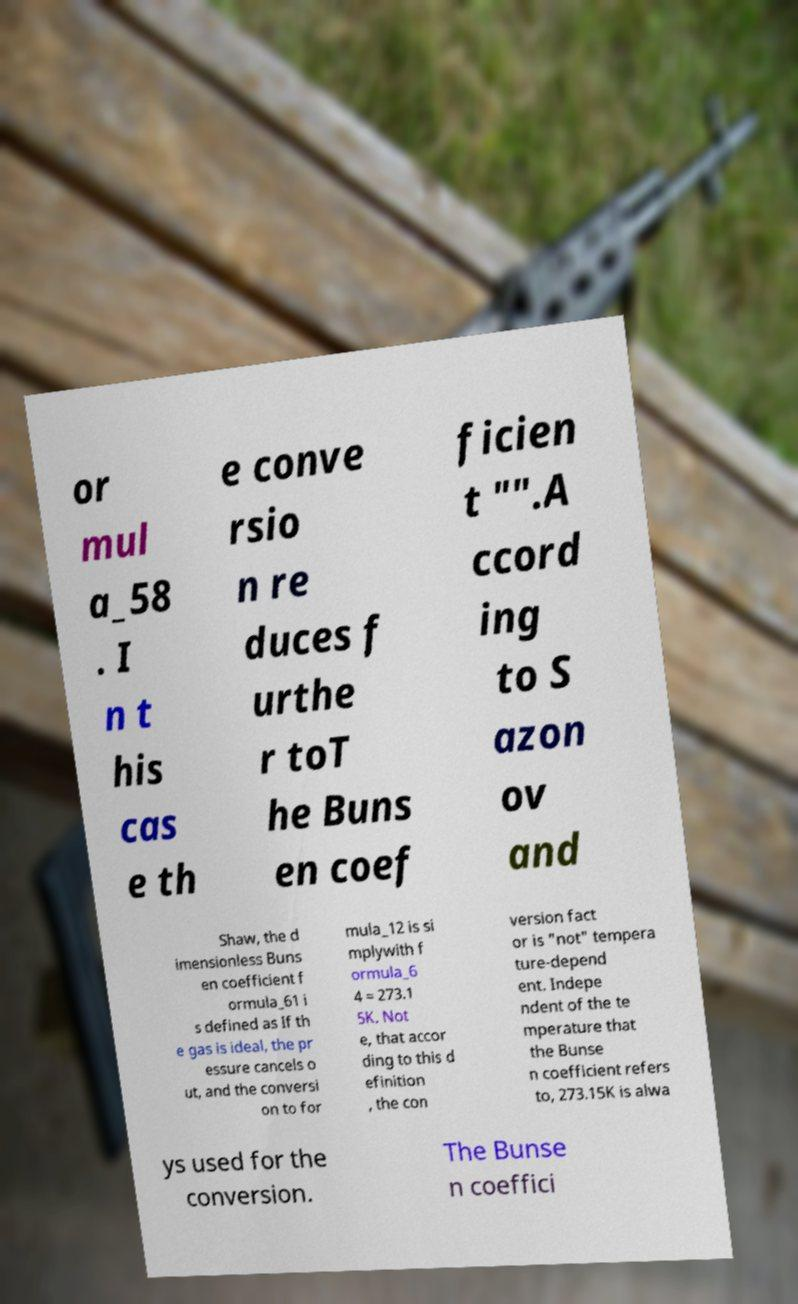Can you read and provide the text displayed in the image?This photo seems to have some interesting text. Can you extract and type it out for me? or mul a_58 . I n t his cas e th e conve rsio n re duces f urthe r toT he Buns en coef ficien t "".A ccord ing to S azon ov and Shaw, the d imensionless Buns en coefficient f ormula_61 i s defined as If th e gas is ideal, the pr essure cancels o ut, and the conversi on to for mula_12 is si mplywith f ormula_6 4 = 273.1 5K. Not e, that accor ding to this d efinition , the con version fact or is "not" tempera ture-depend ent. Indepe ndent of the te mperature that the Bunse n coefficient refers to, 273.15K is alwa ys used for the conversion. The Bunse n coeffici 